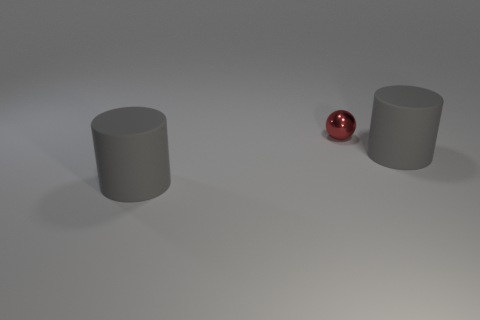Can you tell me what objects are in the image besides the red ball? Besides the shiny red ball, there are two cylindrical grey objects placed on a light surface, both with a matte texture. Their heights appear to differ, adding variety to the shapes presented in the scene. 